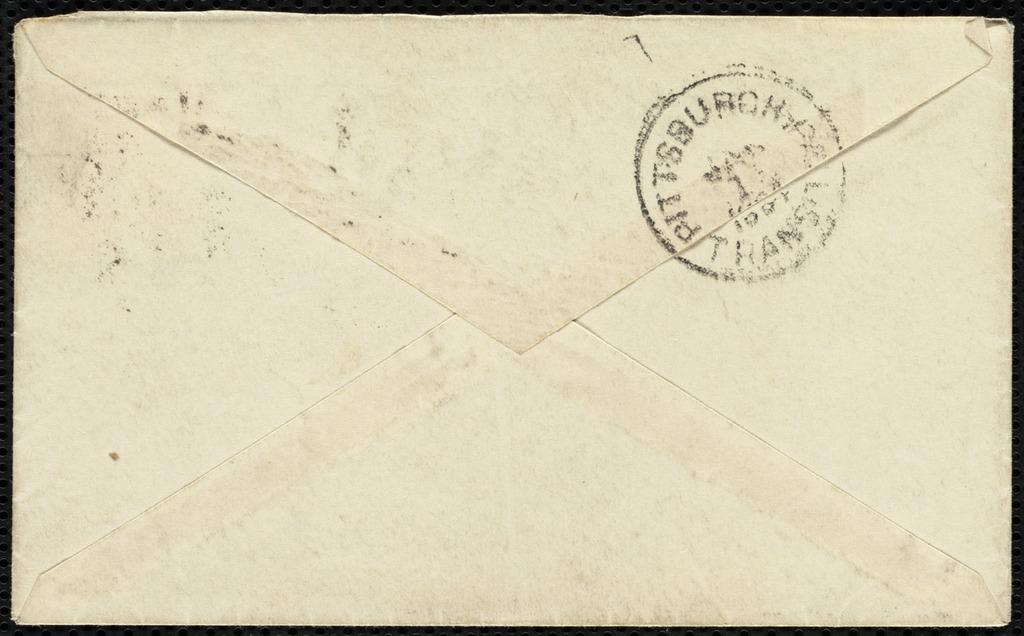What type of object is depicted in the image? The object is an envelope. Is the envelope open or closed? The envelope is closed. Can you identify any additional features on the envelope? Yes, the envelope has a stamp on it. What color is the crayon inside the envelope? There is no crayon present in the image, as the object is an envelope with a stamp on it. 